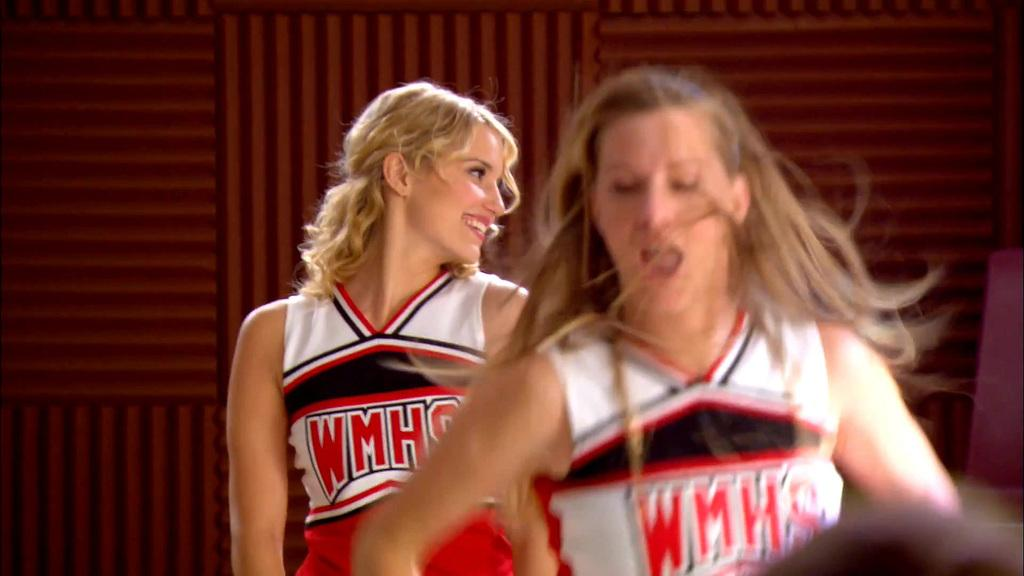<image>
Present a compact description of the photo's key features. Two cheerleaders wearing WMHS uniforms in a room. 